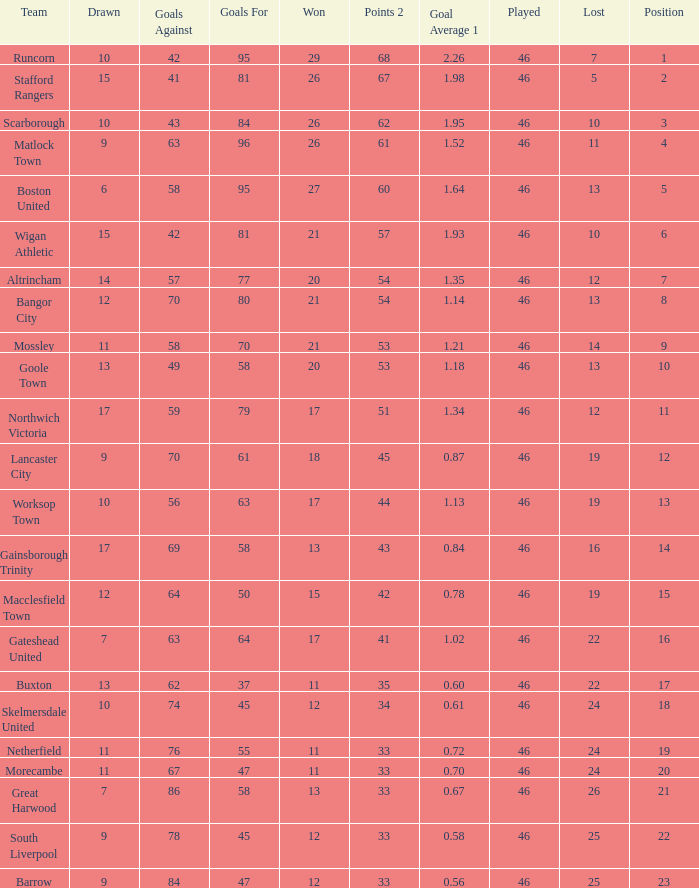Help me parse the entirety of this table. {'header': ['Team', 'Drawn', 'Goals Against', 'Goals For', 'Won', 'Points 2', 'Goal Average 1', 'Played', 'Lost', 'Position'], 'rows': [['Runcorn', '10', '42', '95', '29', '68', '2.26', '46', '7', '1'], ['Stafford Rangers', '15', '41', '81', '26', '67', '1.98', '46', '5', '2'], ['Scarborough', '10', '43', '84', '26', '62', '1.95', '46', '10', '3'], ['Matlock Town', '9', '63', '96', '26', '61', '1.52', '46', '11', '4'], ['Boston United', '6', '58', '95', '27', '60', '1.64', '46', '13', '5'], ['Wigan Athletic', '15', '42', '81', '21', '57', '1.93', '46', '10', '6'], ['Altrincham', '14', '57', '77', '20', '54', '1.35', '46', '12', '7'], ['Bangor City', '12', '70', '80', '21', '54', '1.14', '46', '13', '8'], ['Mossley', '11', '58', '70', '21', '53', '1.21', '46', '14', '9'], ['Goole Town', '13', '49', '58', '20', '53', '1.18', '46', '13', '10'], ['Northwich Victoria', '17', '59', '79', '17', '51', '1.34', '46', '12', '11'], ['Lancaster City', '9', '70', '61', '18', '45', '0.87', '46', '19', '12'], ['Worksop Town', '10', '56', '63', '17', '44', '1.13', '46', '19', '13'], ['Gainsborough Trinity', '17', '69', '58', '13', '43', '0.84', '46', '16', '14'], ['Macclesfield Town', '12', '64', '50', '15', '42', '0.78', '46', '19', '15'], ['Gateshead United', '7', '63', '64', '17', '41', '1.02', '46', '22', '16'], ['Buxton', '13', '62', '37', '11', '35', '0.60', '46', '22', '17'], ['Skelmersdale United', '10', '74', '45', '12', '34', '0.61', '46', '24', '18'], ['Netherfield', '11', '76', '55', '11', '33', '0.72', '46', '24', '19'], ['Morecambe', '11', '67', '47', '11', '33', '0.70', '46', '24', '20'], ['Great Harwood', '7', '86', '58', '13', '33', '0.67', '46', '26', '21'], ['South Liverpool', '9', '78', '45', '12', '33', '0.58', '46', '25', '22'], ['Barrow', '9', '84', '47', '12', '33', '0.56', '46', '25', '23']]} What is the highest position of the Bangor City team? 8.0. 